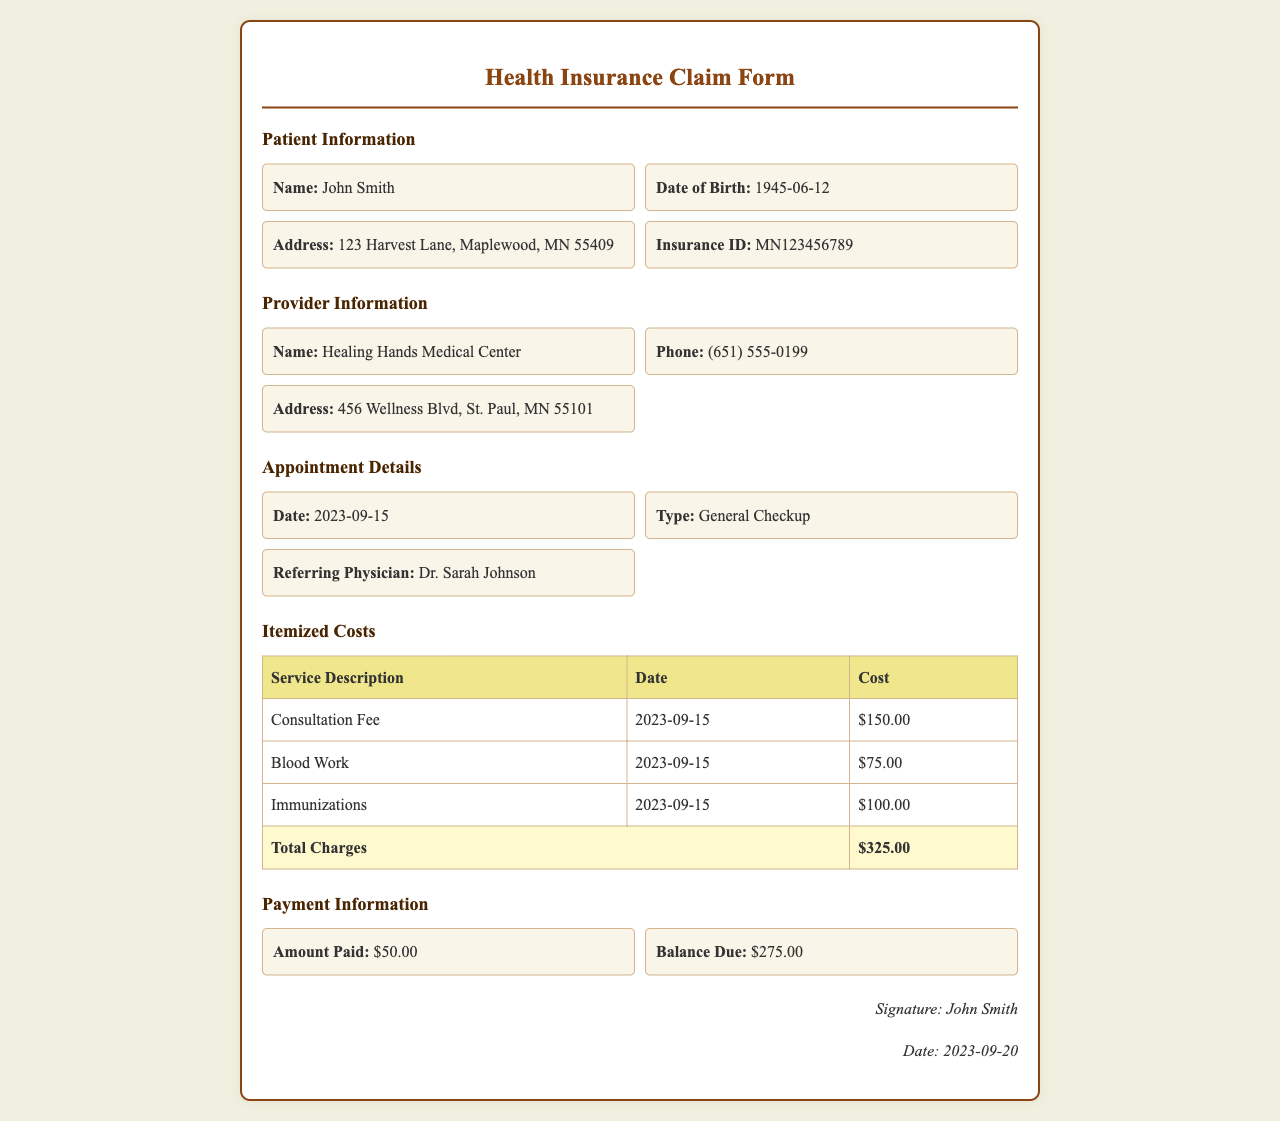What is the patient's name? The patient's name is found in the Patient Information section.
Answer: John Smith What is the total amount charged for services? The total amount charged is indicated at the bottom of the Itemized Costs table.
Answer: $325.00 What was the date of the medical appointment? The appointment date is specified in the Appointment Details section.
Answer: 2023-09-15 How much was paid at the appointment? The amount paid is found in the Payment Information section.
Answer: $50.00 What is the balance due after payment? The balance due is detailed in the Payment Information section.
Answer: $275.00 Who referred the patient for the appointment? The referring physician's name is listed in the Appointment Details section.
Answer: Dr. Sarah Johnson What types of services were provided? The services provided are listed in the Itemized Costs table under Service Description.
Answer: Consultation Fee, Blood Work, Immunizations What is the doctor's phone number? The provider’s phone number is located in the Provider Information section.
Answer: (651) 555-0199 What date was the claim signed? The claim signing date is provided at the bottom of the document.
Answer: 2023-09-20 